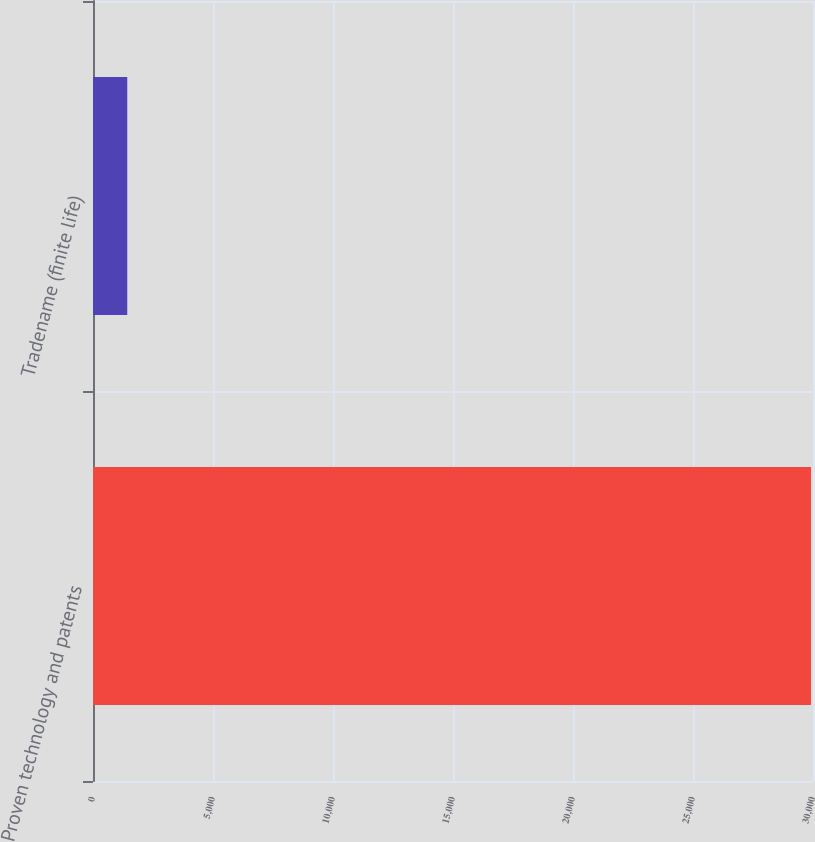Convert chart to OTSL. <chart><loc_0><loc_0><loc_500><loc_500><bar_chart><fcel>Proven technology and patents<fcel>Tradename (finite life)<nl><fcel>29918<fcel>1427<nl></chart> 